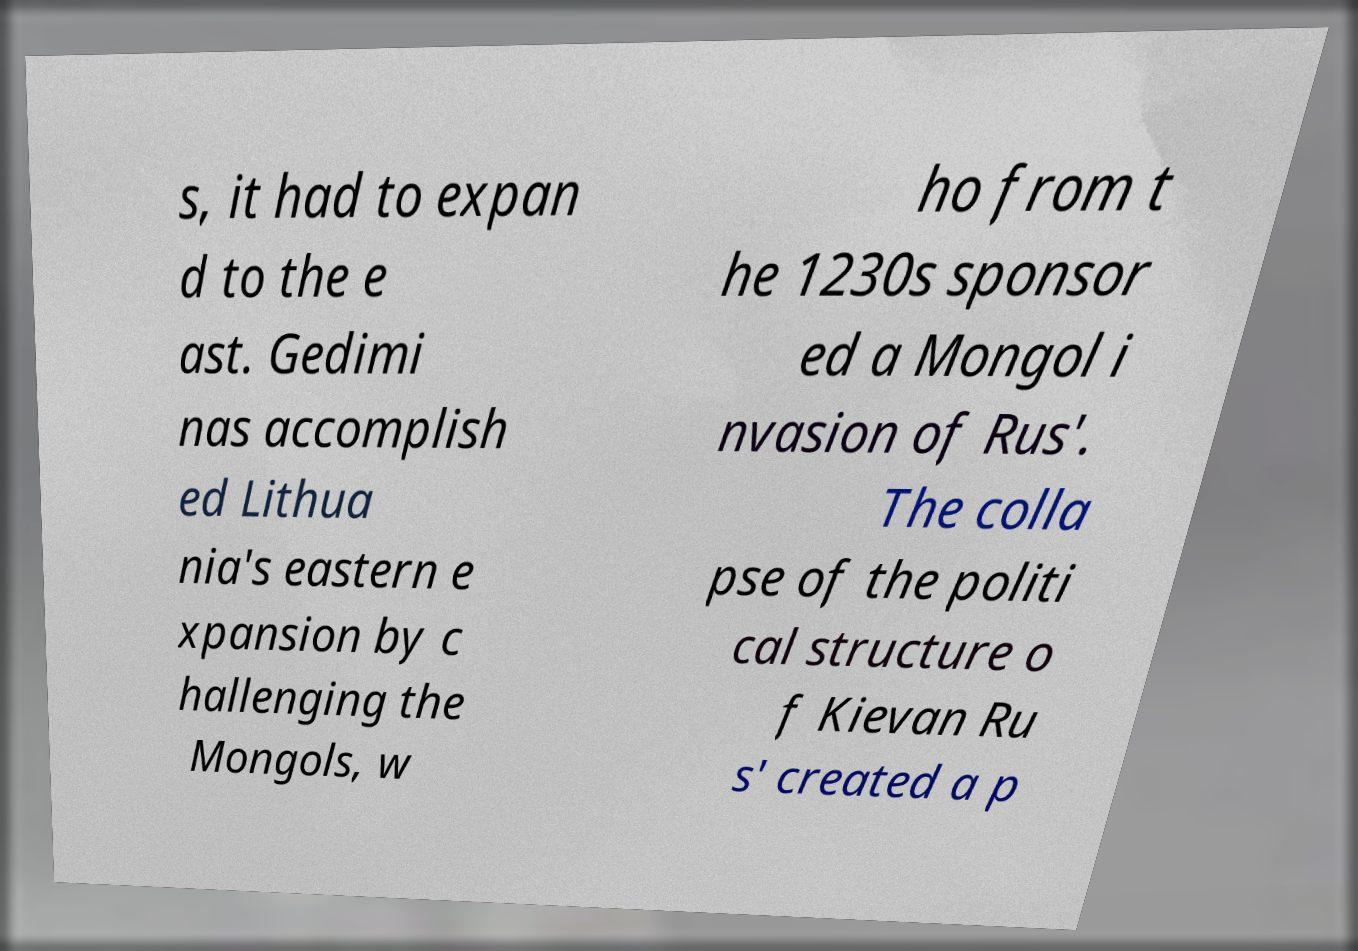Could you assist in decoding the text presented in this image and type it out clearly? s, it had to expan d to the e ast. Gedimi nas accomplish ed Lithua nia's eastern e xpansion by c hallenging the Mongols, w ho from t he 1230s sponsor ed a Mongol i nvasion of Rus'. The colla pse of the politi cal structure o f Kievan Ru s' created a p 